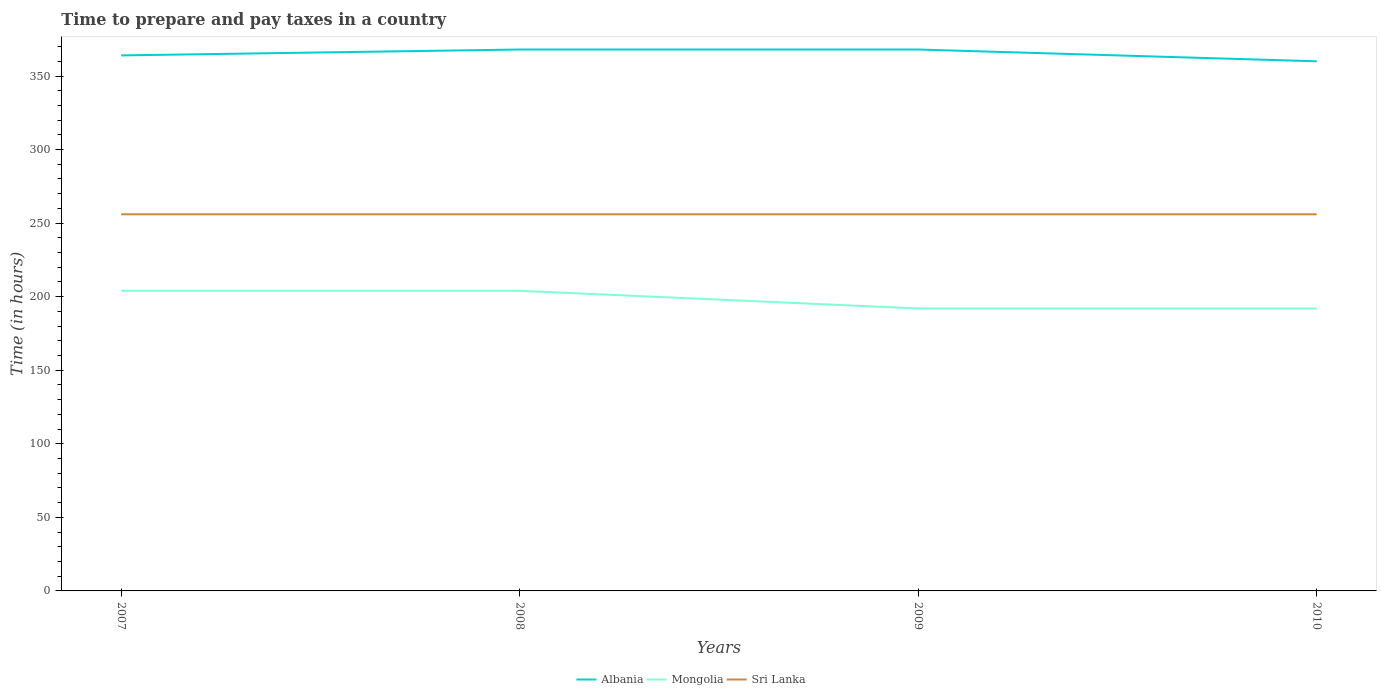How many different coloured lines are there?
Your answer should be very brief. 3. Does the line corresponding to Albania intersect with the line corresponding to Mongolia?
Your answer should be compact. No. Across all years, what is the maximum number of hours required to prepare and pay taxes in Mongolia?
Keep it short and to the point. 192. What is the difference between the highest and the second highest number of hours required to prepare and pay taxes in Mongolia?
Provide a short and direct response. 12. Is the number of hours required to prepare and pay taxes in Albania strictly greater than the number of hours required to prepare and pay taxes in Sri Lanka over the years?
Make the answer very short. No. Does the graph contain any zero values?
Your response must be concise. No. Does the graph contain grids?
Give a very brief answer. No. Where does the legend appear in the graph?
Your response must be concise. Bottom center. How are the legend labels stacked?
Your answer should be very brief. Horizontal. What is the title of the graph?
Ensure brevity in your answer.  Time to prepare and pay taxes in a country. Does "Venezuela" appear as one of the legend labels in the graph?
Provide a short and direct response. No. What is the label or title of the X-axis?
Your response must be concise. Years. What is the label or title of the Y-axis?
Make the answer very short. Time (in hours). What is the Time (in hours) in Albania in 2007?
Provide a succinct answer. 364. What is the Time (in hours) of Mongolia in 2007?
Offer a very short reply. 204. What is the Time (in hours) of Sri Lanka in 2007?
Provide a short and direct response. 256. What is the Time (in hours) of Albania in 2008?
Keep it short and to the point. 368. What is the Time (in hours) of Mongolia in 2008?
Offer a terse response. 204. What is the Time (in hours) in Sri Lanka in 2008?
Give a very brief answer. 256. What is the Time (in hours) of Albania in 2009?
Keep it short and to the point. 368. What is the Time (in hours) of Mongolia in 2009?
Make the answer very short. 192. What is the Time (in hours) of Sri Lanka in 2009?
Make the answer very short. 256. What is the Time (in hours) in Albania in 2010?
Give a very brief answer. 360. What is the Time (in hours) in Mongolia in 2010?
Ensure brevity in your answer.  192. What is the Time (in hours) of Sri Lanka in 2010?
Ensure brevity in your answer.  256. Across all years, what is the maximum Time (in hours) in Albania?
Ensure brevity in your answer.  368. Across all years, what is the maximum Time (in hours) in Mongolia?
Provide a succinct answer. 204. Across all years, what is the maximum Time (in hours) in Sri Lanka?
Make the answer very short. 256. Across all years, what is the minimum Time (in hours) of Albania?
Keep it short and to the point. 360. Across all years, what is the minimum Time (in hours) of Mongolia?
Make the answer very short. 192. Across all years, what is the minimum Time (in hours) of Sri Lanka?
Your answer should be very brief. 256. What is the total Time (in hours) in Albania in the graph?
Your answer should be very brief. 1460. What is the total Time (in hours) of Mongolia in the graph?
Provide a succinct answer. 792. What is the total Time (in hours) in Sri Lanka in the graph?
Give a very brief answer. 1024. What is the difference between the Time (in hours) in Albania in 2007 and that in 2008?
Offer a very short reply. -4. What is the difference between the Time (in hours) of Albania in 2007 and that in 2009?
Offer a terse response. -4. What is the difference between the Time (in hours) in Albania in 2007 and that in 2010?
Make the answer very short. 4. What is the difference between the Time (in hours) in Sri Lanka in 2008 and that in 2009?
Your answer should be very brief. 0. What is the difference between the Time (in hours) in Albania in 2008 and that in 2010?
Keep it short and to the point. 8. What is the difference between the Time (in hours) in Mongolia in 2009 and that in 2010?
Keep it short and to the point. 0. What is the difference between the Time (in hours) of Sri Lanka in 2009 and that in 2010?
Provide a short and direct response. 0. What is the difference between the Time (in hours) in Albania in 2007 and the Time (in hours) in Mongolia in 2008?
Offer a very short reply. 160. What is the difference between the Time (in hours) of Albania in 2007 and the Time (in hours) of Sri Lanka in 2008?
Your response must be concise. 108. What is the difference between the Time (in hours) of Mongolia in 2007 and the Time (in hours) of Sri Lanka in 2008?
Provide a short and direct response. -52. What is the difference between the Time (in hours) of Albania in 2007 and the Time (in hours) of Mongolia in 2009?
Keep it short and to the point. 172. What is the difference between the Time (in hours) of Albania in 2007 and the Time (in hours) of Sri Lanka in 2009?
Keep it short and to the point. 108. What is the difference between the Time (in hours) in Mongolia in 2007 and the Time (in hours) in Sri Lanka in 2009?
Offer a very short reply. -52. What is the difference between the Time (in hours) of Albania in 2007 and the Time (in hours) of Mongolia in 2010?
Your answer should be very brief. 172. What is the difference between the Time (in hours) in Albania in 2007 and the Time (in hours) in Sri Lanka in 2010?
Your response must be concise. 108. What is the difference between the Time (in hours) in Mongolia in 2007 and the Time (in hours) in Sri Lanka in 2010?
Make the answer very short. -52. What is the difference between the Time (in hours) in Albania in 2008 and the Time (in hours) in Mongolia in 2009?
Your response must be concise. 176. What is the difference between the Time (in hours) in Albania in 2008 and the Time (in hours) in Sri Lanka in 2009?
Your response must be concise. 112. What is the difference between the Time (in hours) in Mongolia in 2008 and the Time (in hours) in Sri Lanka in 2009?
Offer a terse response. -52. What is the difference between the Time (in hours) of Albania in 2008 and the Time (in hours) of Mongolia in 2010?
Keep it short and to the point. 176. What is the difference between the Time (in hours) of Albania in 2008 and the Time (in hours) of Sri Lanka in 2010?
Your answer should be very brief. 112. What is the difference between the Time (in hours) in Mongolia in 2008 and the Time (in hours) in Sri Lanka in 2010?
Your answer should be very brief. -52. What is the difference between the Time (in hours) in Albania in 2009 and the Time (in hours) in Mongolia in 2010?
Your answer should be compact. 176. What is the difference between the Time (in hours) in Albania in 2009 and the Time (in hours) in Sri Lanka in 2010?
Offer a very short reply. 112. What is the difference between the Time (in hours) in Mongolia in 2009 and the Time (in hours) in Sri Lanka in 2010?
Keep it short and to the point. -64. What is the average Time (in hours) in Albania per year?
Provide a succinct answer. 365. What is the average Time (in hours) in Mongolia per year?
Ensure brevity in your answer.  198. What is the average Time (in hours) of Sri Lanka per year?
Provide a short and direct response. 256. In the year 2007, what is the difference between the Time (in hours) of Albania and Time (in hours) of Mongolia?
Give a very brief answer. 160. In the year 2007, what is the difference between the Time (in hours) of Albania and Time (in hours) of Sri Lanka?
Your answer should be compact. 108. In the year 2007, what is the difference between the Time (in hours) of Mongolia and Time (in hours) of Sri Lanka?
Your answer should be compact. -52. In the year 2008, what is the difference between the Time (in hours) of Albania and Time (in hours) of Mongolia?
Provide a succinct answer. 164. In the year 2008, what is the difference between the Time (in hours) in Albania and Time (in hours) in Sri Lanka?
Your response must be concise. 112. In the year 2008, what is the difference between the Time (in hours) of Mongolia and Time (in hours) of Sri Lanka?
Your answer should be very brief. -52. In the year 2009, what is the difference between the Time (in hours) of Albania and Time (in hours) of Mongolia?
Your answer should be very brief. 176. In the year 2009, what is the difference between the Time (in hours) of Albania and Time (in hours) of Sri Lanka?
Give a very brief answer. 112. In the year 2009, what is the difference between the Time (in hours) of Mongolia and Time (in hours) of Sri Lanka?
Keep it short and to the point. -64. In the year 2010, what is the difference between the Time (in hours) of Albania and Time (in hours) of Mongolia?
Give a very brief answer. 168. In the year 2010, what is the difference between the Time (in hours) in Albania and Time (in hours) in Sri Lanka?
Give a very brief answer. 104. In the year 2010, what is the difference between the Time (in hours) of Mongolia and Time (in hours) of Sri Lanka?
Provide a short and direct response. -64. What is the ratio of the Time (in hours) in Albania in 2007 to that in 2008?
Your answer should be compact. 0.99. What is the ratio of the Time (in hours) in Albania in 2007 to that in 2009?
Offer a terse response. 0.99. What is the ratio of the Time (in hours) of Sri Lanka in 2007 to that in 2009?
Your response must be concise. 1. What is the ratio of the Time (in hours) of Albania in 2007 to that in 2010?
Your response must be concise. 1.01. What is the ratio of the Time (in hours) of Mongolia in 2007 to that in 2010?
Your response must be concise. 1.06. What is the ratio of the Time (in hours) of Sri Lanka in 2007 to that in 2010?
Give a very brief answer. 1. What is the ratio of the Time (in hours) of Albania in 2008 to that in 2009?
Provide a short and direct response. 1. What is the ratio of the Time (in hours) in Sri Lanka in 2008 to that in 2009?
Your answer should be compact. 1. What is the ratio of the Time (in hours) of Albania in 2008 to that in 2010?
Your response must be concise. 1.02. What is the ratio of the Time (in hours) in Mongolia in 2008 to that in 2010?
Your answer should be compact. 1.06. What is the ratio of the Time (in hours) of Sri Lanka in 2008 to that in 2010?
Make the answer very short. 1. What is the ratio of the Time (in hours) of Albania in 2009 to that in 2010?
Provide a succinct answer. 1.02. What is the ratio of the Time (in hours) of Sri Lanka in 2009 to that in 2010?
Your answer should be very brief. 1. What is the difference between the highest and the second highest Time (in hours) of Mongolia?
Give a very brief answer. 0. What is the difference between the highest and the second highest Time (in hours) of Sri Lanka?
Your answer should be very brief. 0. 